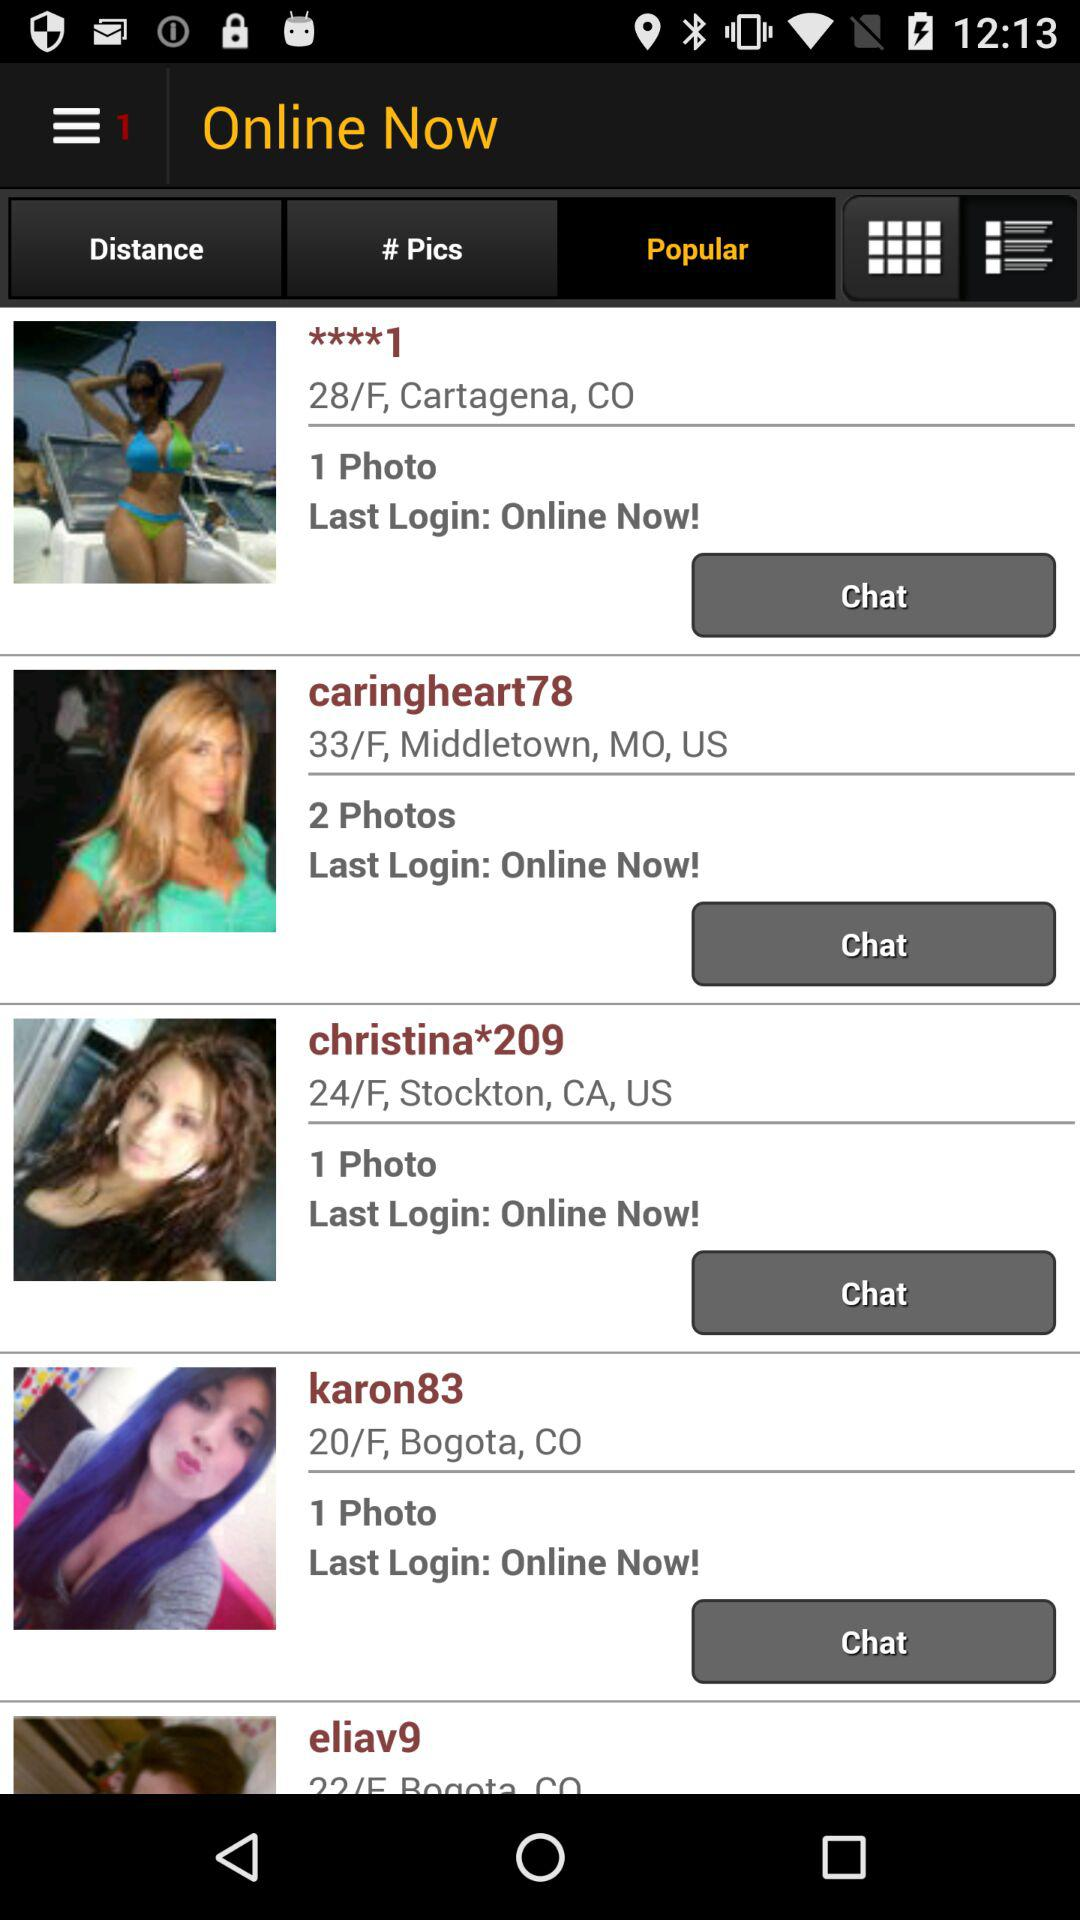What is the address of "karon83"? The address of "karon83" is 20/F, Bogota, CO. 